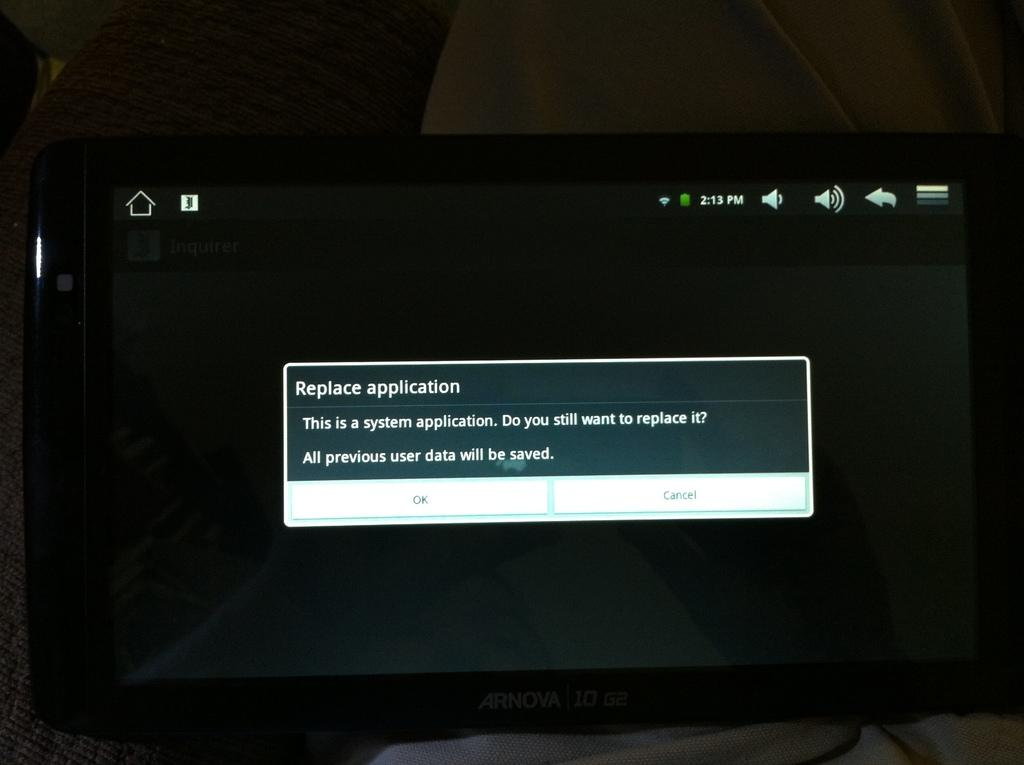<image>
Summarize the visual content of the image. A computer display shows a message asking the user to replace application. 